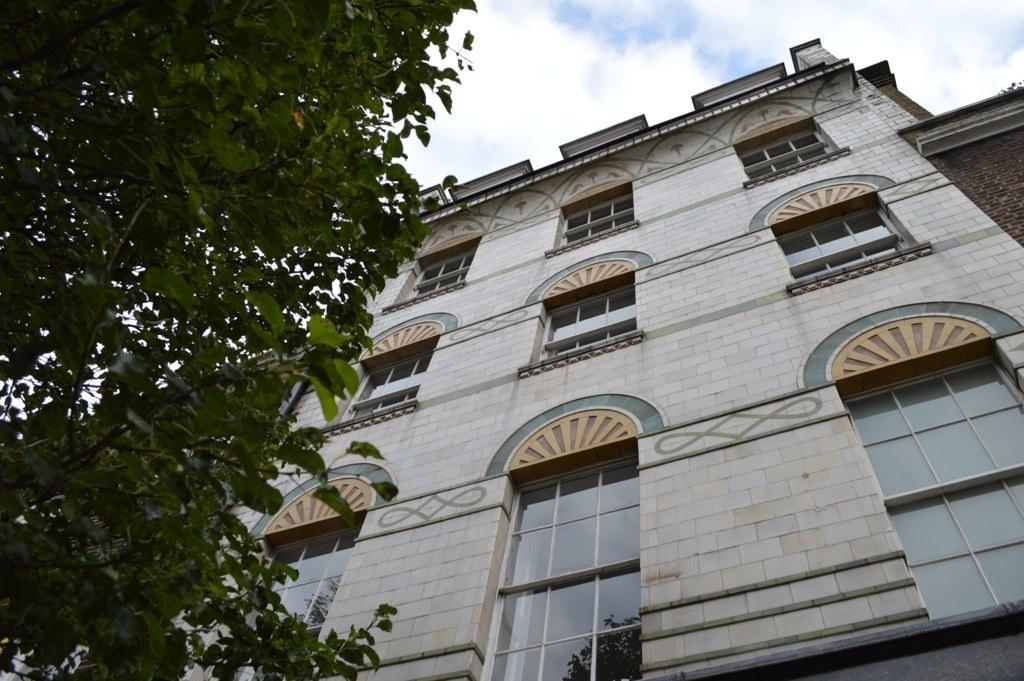What type of structure is present in the image? There is a building in the image. What other elements can be seen in the image besides the building? There are trees in the image. What part of the natural environment is visible in the image? The sky is visible in the image. What type of fowl can be seen perched on the record in the image? There is no record or fowl present in the image. 